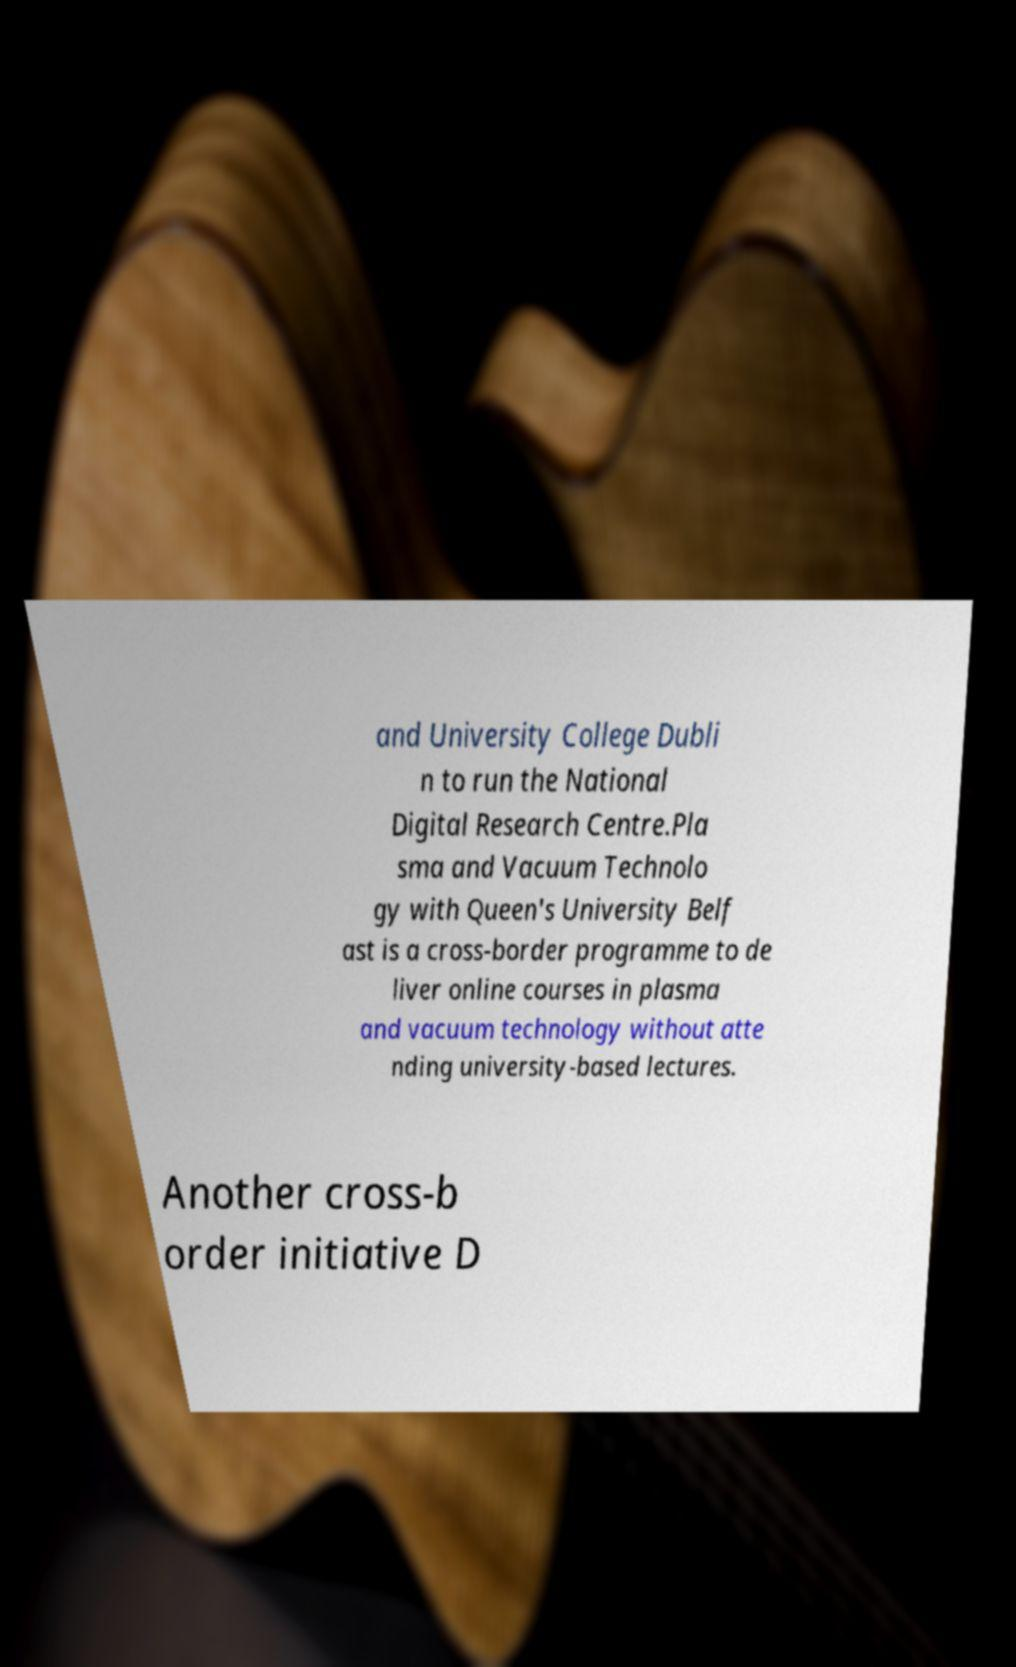Could you extract and type out the text from this image? and University College Dubli n to run the National Digital Research Centre.Pla sma and Vacuum Technolo gy with Queen's University Belf ast is a cross-border programme to de liver online courses in plasma and vacuum technology without atte nding university-based lectures. Another cross-b order initiative D 